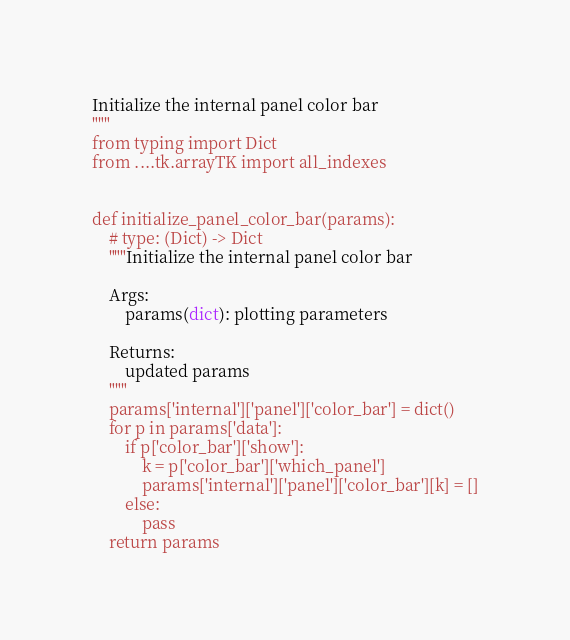<code> <loc_0><loc_0><loc_500><loc_500><_Python_>Initialize the internal panel color bar
"""
from typing import Dict
from ....tk.arrayTK import all_indexes


def initialize_panel_color_bar(params):
    # type: (Dict) -> Dict
    """Initialize the internal panel color bar

    Args:
        params(dict): plotting parameters

    Returns:
        updated params
    """
    params['internal']['panel']['color_bar'] = dict()
    for p in params['data']:
        if p['color_bar']['show']:
            k = p['color_bar']['which_panel']
            params['internal']['panel']['color_bar'][k] = []
        else:
            pass
    return params
</code> 